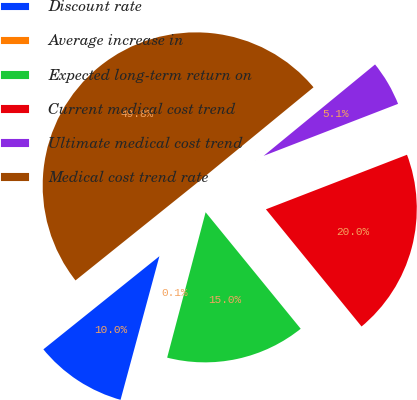<chart> <loc_0><loc_0><loc_500><loc_500><pie_chart><fcel>Discount rate<fcel>Average increase in<fcel>Expected long-term return on<fcel>Current medical cost trend<fcel>Ultimate medical cost trend<fcel>Medical cost trend rate<nl><fcel>10.03%<fcel>0.09%<fcel>15.01%<fcel>19.98%<fcel>5.06%<fcel>49.83%<nl></chart> 